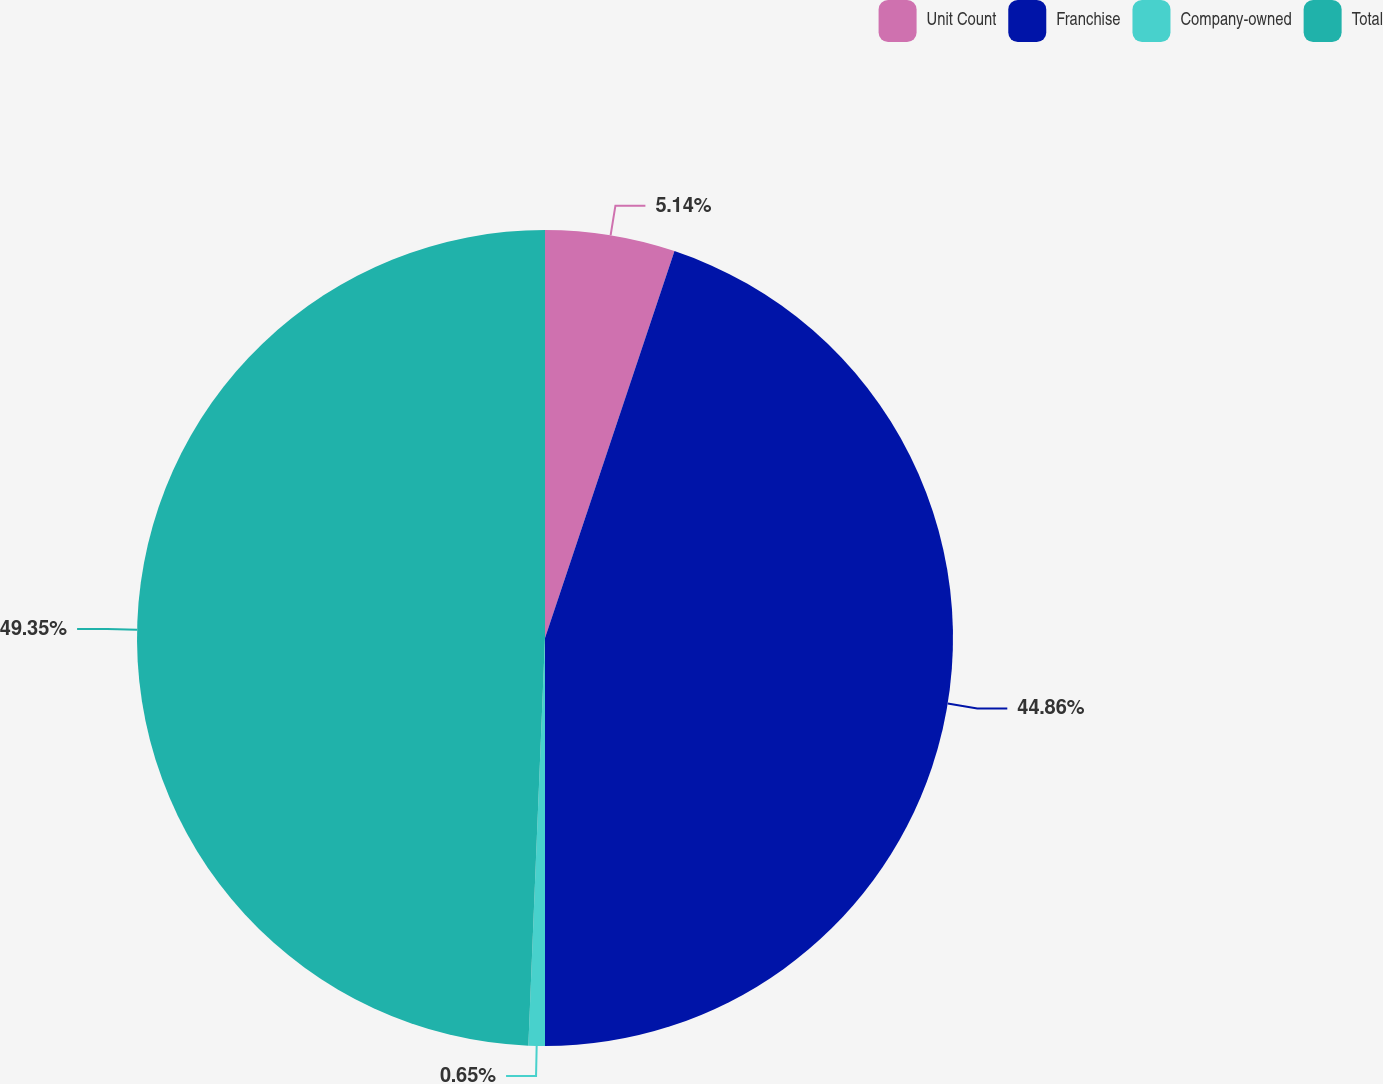Convert chart. <chart><loc_0><loc_0><loc_500><loc_500><pie_chart><fcel>Unit Count<fcel>Franchise<fcel>Company-owned<fcel>Total<nl><fcel>5.14%<fcel>44.86%<fcel>0.65%<fcel>49.35%<nl></chart> 